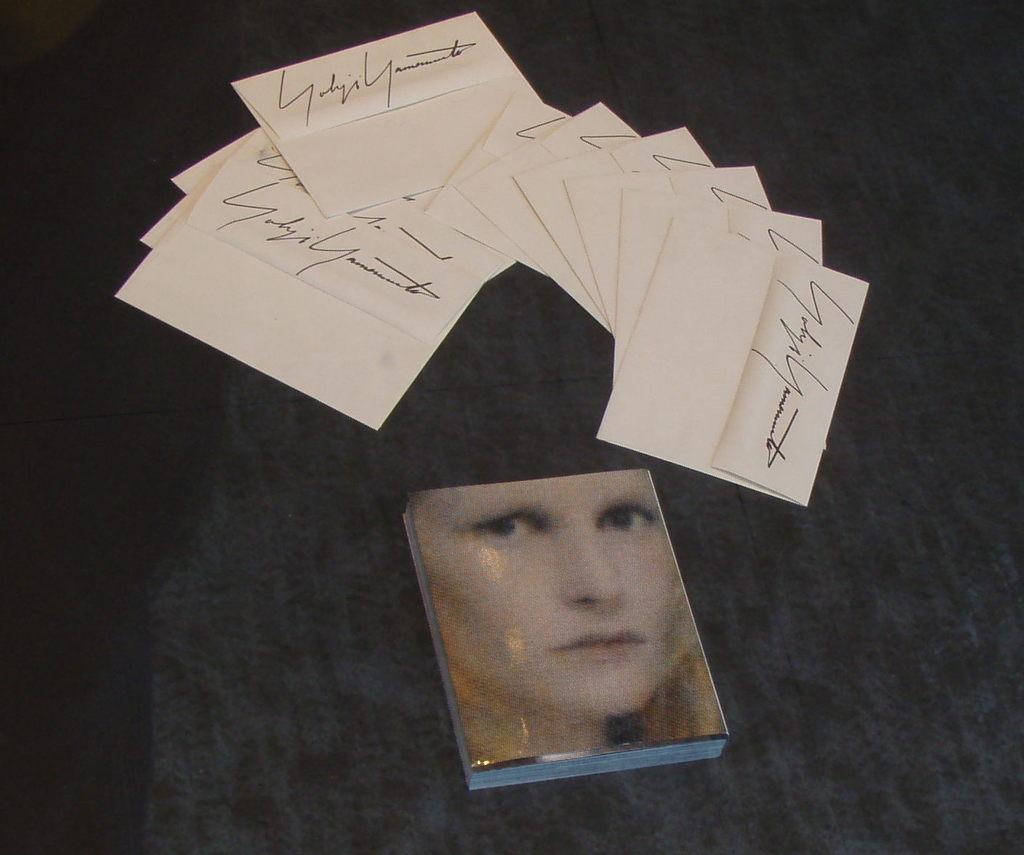What is the main object in the image? There is a book in the image. What other items can be seen in the image? There are envelopes in the image. What is the color of the surface the book and envelopes are on? The surface the book and envelopes are on is black. Is there a fight happening between the book and the envelopes in the image? No, there is no fight happening between the book and the envelopes in the image. 